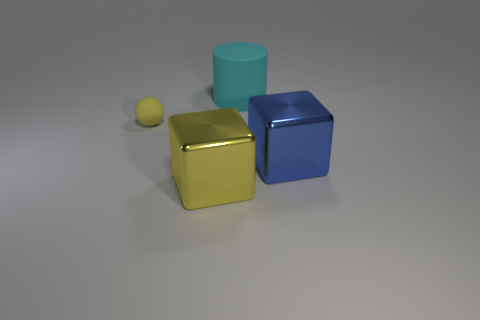What materials appear to be depicted in the objects shown? The objects seem to mimic realistic materials. The cube in the forefront has a metallic sheen suggestive of metal, and the sphere appears to have a matte finish that could be indicative of a clay or plastic composition. The cylinder in the background has a slightly glossy appearance, suggesting it might be made of a reflective material like plastic or polished ceramic. 